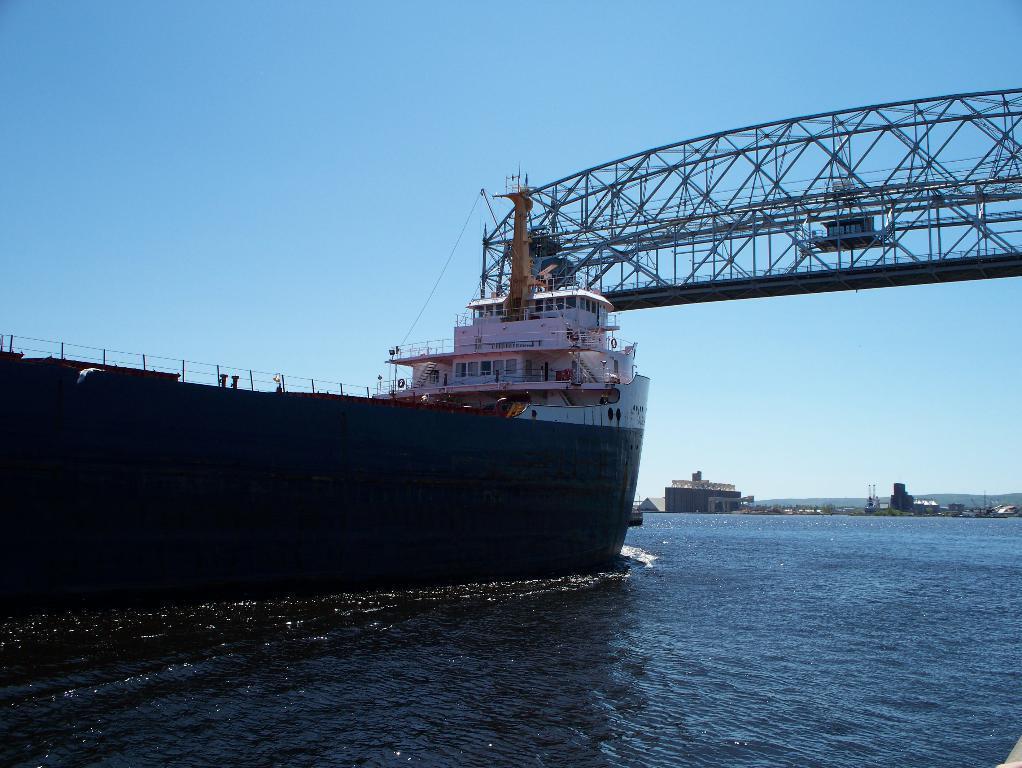In one or two sentences, can you explain what this image depicts? This is the ship moving on the water. This looks like an iron bridge. In the background, I can see a small building. 